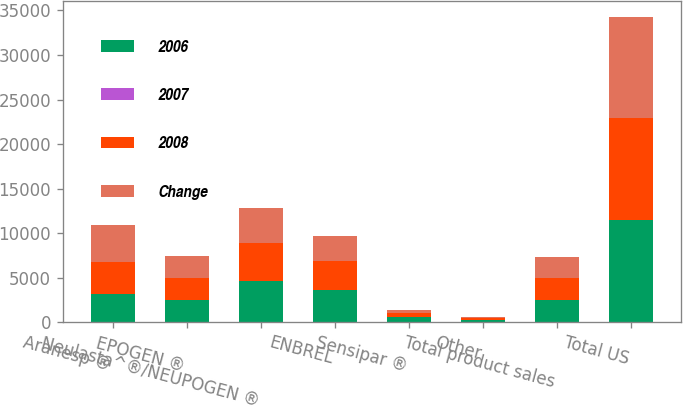<chart> <loc_0><loc_0><loc_500><loc_500><stacked_bar_chart><ecel><fcel>Aranesp ®<fcel>EPOGEN ®<fcel>Neulasta^®/NEUPOGEN ®<fcel>ENBREL<fcel>Sensipar ®<fcel>Other<fcel>Total product sales<fcel>Total US<nl><fcel>2006<fcel>3137<fcel>2456<fcel>4659<fcel>3598<fcel>597<fcel>240<fcel>2456<fcel>11460<nl><fcel>2007<fcel>13<fcel>1<fcel>9<fcel>11<fcel>29<fcel>1<fcel>3<fcel>0<nl><fcel>2008<fcel>3614<fcel>2489<fcel>4277<fcel>3230<fcel>463<fcel>238<fcel>2456<fcel>11443<nl><fcel>Change<fcel>4121<fcel>2511<fcel>3923<fcel>2879<fcel>321<fcel>103<fcel>2456<fcel>11397<nl></chart> 